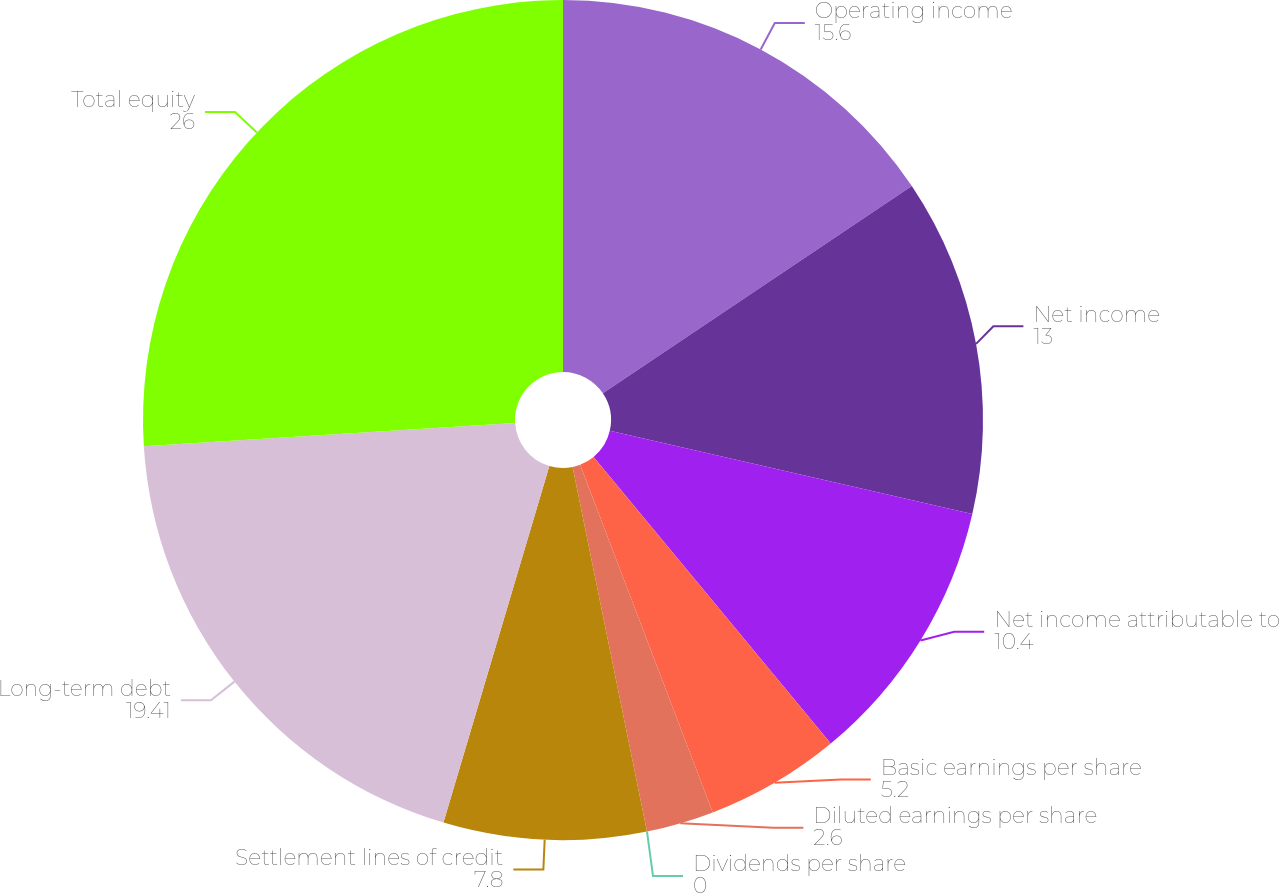<chart> <loc_0><loc_0><loc_500><loc_500><pie_chart><fcel>Operating income<fcel>Net income<fcel>Net income attributable to<fcel>Basic earnings per share<fcel>Diluted earnings per share<fcel>Dividends per share<fcel>Settlement lines of credit<fcel>Long-term debt<fcel>Total equity<nl><fcel>15.6%<fcel>13.0%<fcel>10.4%<fcel>5.2%<fcel>2.6%<fcel>0.0%<fcel>7.8%<fcel>19.41%<fcel>26.0%<nl></chart> 